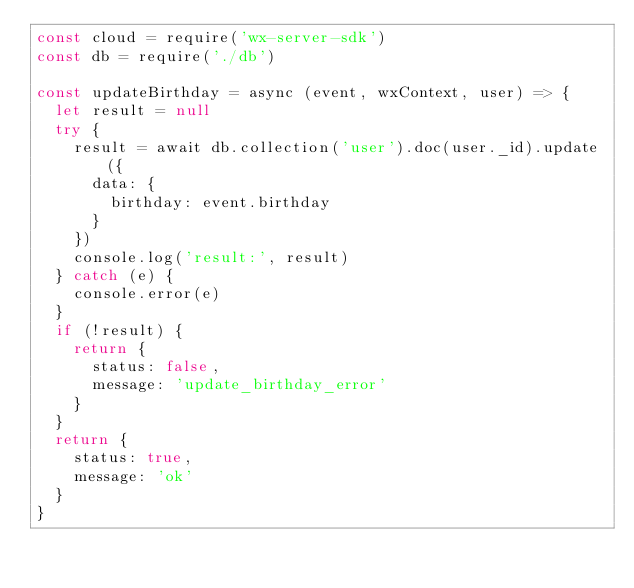Convert code to text. <code><loc_0><loc_0><loc_500><loc_500><_JavaScript_>const cloud = require('wx-server-sdk')
const db = require('./db')

const updateBirthday = async (event, wxContext, user) => {
  let result = null
  try {
    result = await db.collection('user').doc(user._id).update({
      data: {
        birthday: event.birthday
      }
    })
    console.log('result:', result)
  } catch (e) {
    console.error(e)
  }
  if (!result) {
    return {
      status: false,
      message: 'update_birthday_error'
    }
  }
  return {
    status: true,
    message: 'ok'
  }
}
</code> 